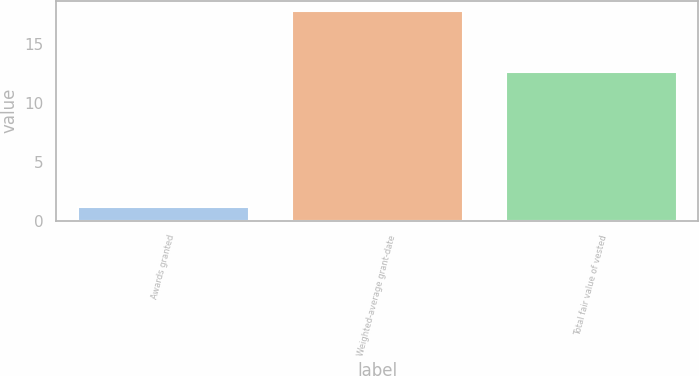Convert chart to OTSL. <chart><loc_0><loc_0><loc_500><loc_500><bar_chart><fcel>Awards granted<fcel>Weighted-average grant-date<fcel>Total fair value of vested<nl><fcel>1.2<fcel>17.77<fcel>12.6<nl></chart> 